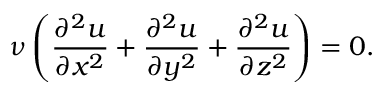<formula> <loc_0><loc_0><loc_500><loc_500>\nu \left ( { \frac { \partial ^ { 2 } u } { \partial x ^ { 2 } } } + { \frac { \partial ^ { 2 } u } { \partial y ^ { 2 } } } + { \frac { \partial ^ { 2 } u } { \partial z ^ { 2 } } } \right ) = 0 .</formula> 